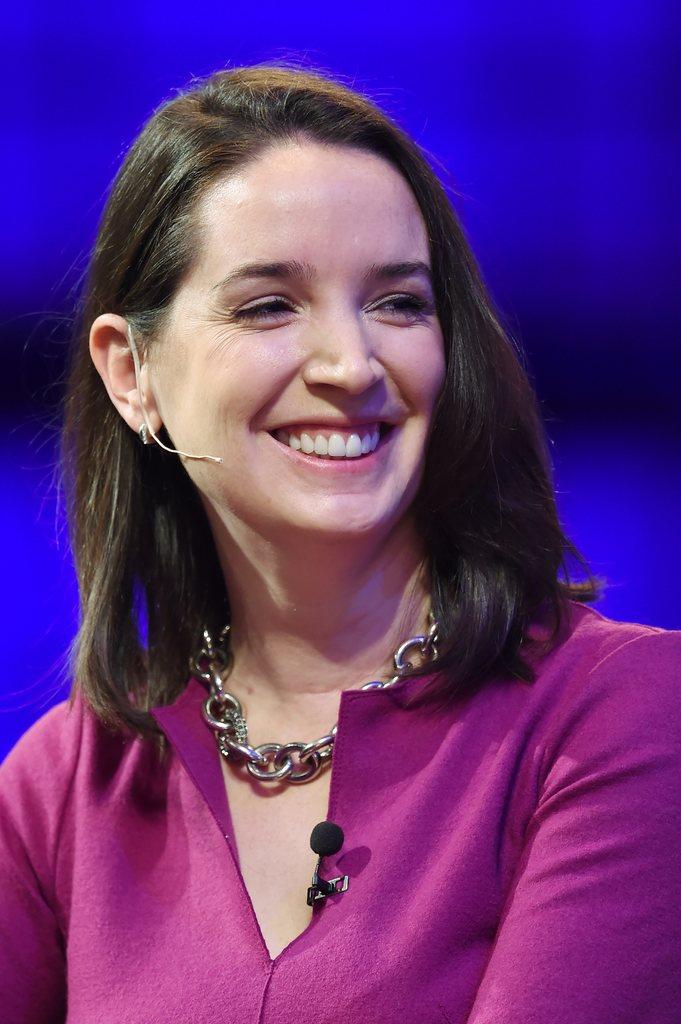What is the main subject of the image? There is a woman in the image. What is the woman's facial expression? The woman is smiling. What does the caption below the image say? There is no caption present in the image, so it cannot be read or described. 